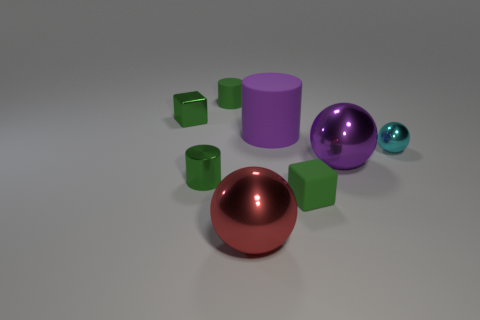Add 1 gray matte objects. How many objects exist? 9 Subtract all blocks. How many objects are left? 6 Add 5 green blocks. How many green blocks are left? 7 Add 8 cyan balls. How many cyan balls exist? 9 Subtract 0 blue spheres. How many objects are left? 8 Subtract all small cyan metal objects. Subtract all cylinders. How many objects are left? 4 